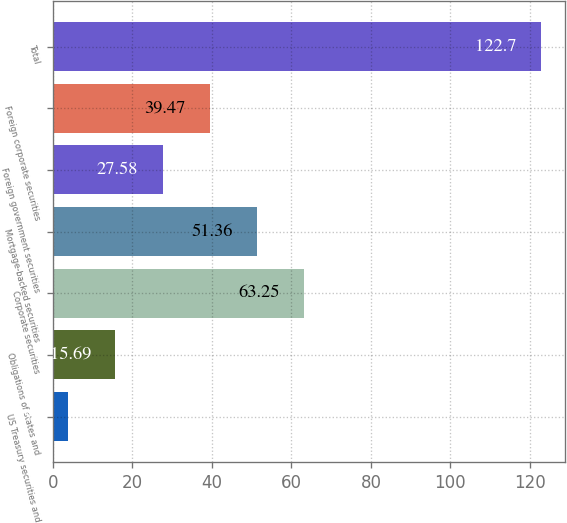<chart> <loc_0><loc_0><loc_500><loc_500><bar_chart><fcel>US Treasury securities and<fcel>Obligations of states and<fcel>Corporate securities<fcel>Mortgage-backed securities<fcel>Foreign government securities<fcel>Foreign corporate securities<fcel>Total<nl><fcel>3.8<fcel>15.69<fcel>63.25<fcel>51.36<fcel>27.58<fcel>39.47<fcel>122.7<nl></chart> 